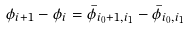Convert formula to latex. <formula><loc_0><loc_0><loc_500><loc_500>\phi _ { i + 1 } - \phi _ { i } = \bar { \phi } _ { i _ { 0 } + 1 , i _ { 1 } } - \bar { \phi } _ { i _ { 0 } , i _ { 1 } }</formula> 